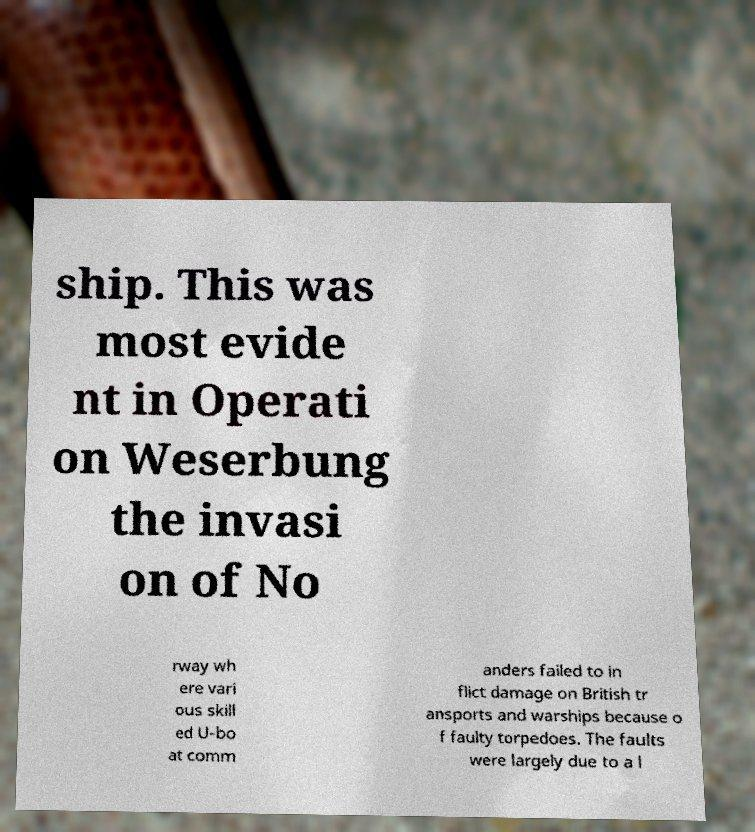What messages or text are displayed in this image? I need them in a readable, typed format. ship. This was most evide nt in Operati on Weserbung the invasi on of No rway wh ere vari ous skill ed U-bo at comm anders failed to in flict damage on British tr ansports and warships because o f faulty torpedoes. The faults were largely due to a l 